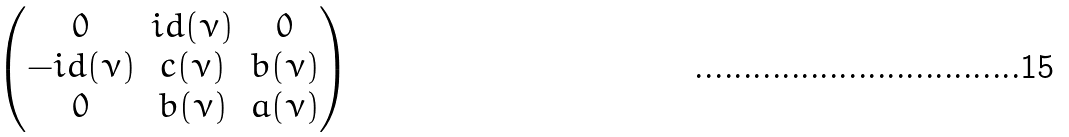Convert formula to latex. <formula><loc_0><loc_0><loc_500><loc_500>\begin{pmatrix} 0 & i d ( \nu ) & 0 \\ - i d ( \nu ) & c ( \nu ) & b ( \nu ) \\ 0 & b ( \nu ) & a ( \nu ) \end{pmatrix}</formula> 